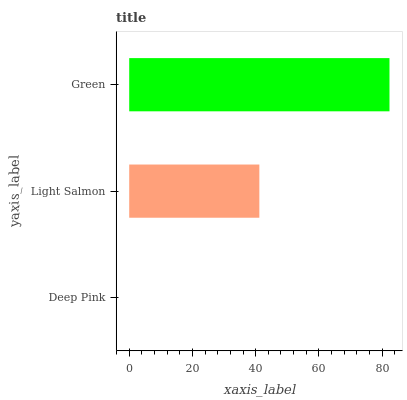Is Deep Pink the minimum?
Answer yes or no. Yes. Is Green the maximum?
Answer yes or no. Yes. Is Light Salmon the minimum?
Answer yes or no. No. Is Light Salmon the maximum?
Answer yes or no. No. Is Light Salmon greater than Deep Pink?
Answer yes or no. Yes. Is Deep Pink less than Light Salmon?
Answer yes or no. Yes. Is Deep Pink greater than Light Salmon?
Answer yes or no. No. Is Light Salmon less than Deep Pink?
Answer yes or no. No. Is Light Salmon the high median?
Answer yes or no. Yes. Is Light Salmon the low median?
Answer yes or no. Yes. Is Deep Pink the high median?
Answer yes or no. No. Is Deep Pink the low median?
Answer yes or no. No. 